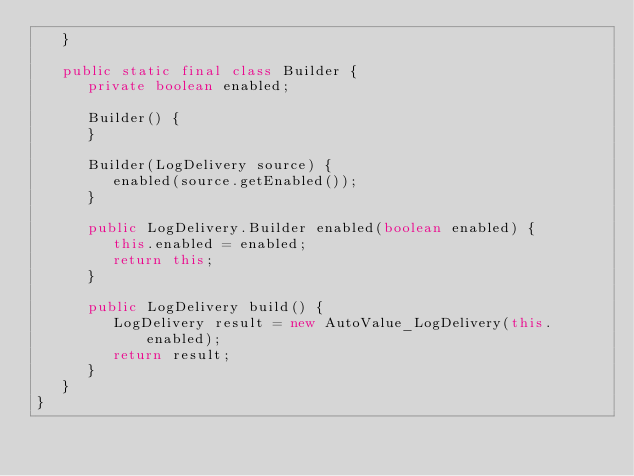Convert code to text. <code><loc_0><loc_0><loc_500><loc_500><_Java_>   }

   public static final class Builder {
      private boolean enabled;

      Builder() {
      }

      Builder(LogDelivery source) {
         enabled(source.getEnabled());
      }

      public LogDelivery.Builder enabled(boolean enabled) {
         this.enabled = enabled;
         return this;
      }

      public LogDelivery build() {
         LogDelivery result = new AutoValue_LogDelivery(this.enabled);
         return result;
      }
   }
}
</code> 